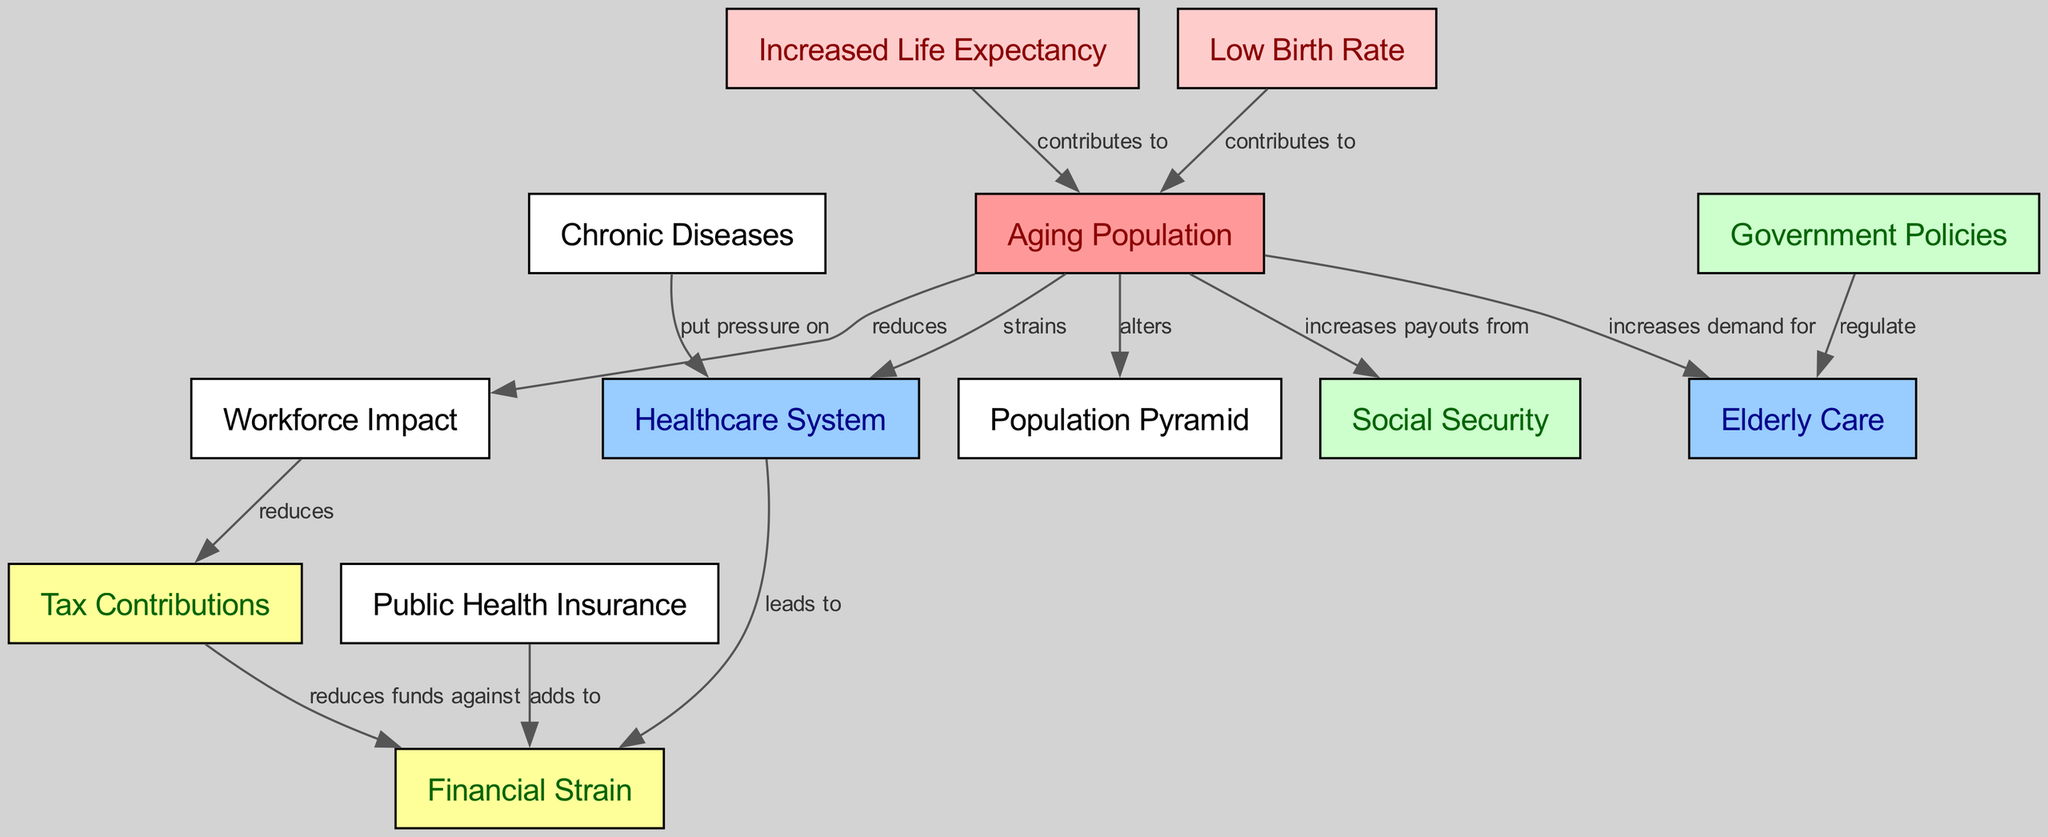What is the main cause contributing to the aging population? According to the diagram, the nodes "Increased Life Expectancy" and "Low Birth Rate" both contribute to "Aging Population." Therefore, either could be selected as a main cause; however, they are specifically indicated to lead to the aging issue.
Answer: Increased Life Expectancy or Low Birth Rate How many nodes are there in total? By counting all the unique entities in the diagram, we find there are 13 individual nodes present related to the aging population crisis and its impact on the healthcare system.
Answer: 13 What relationship does the aging population have with the healthcare system? The diagram shows that the relationship is that the "Aging Population" strains the "Healthcare System." This indicates a direct impact of an increasing elderly population on healthcare resources.
Answer: strains Which factor directly increases demand for elderly care? The diagram specifies that the "Aging Population" leads to an increased demand for "Elderly Care," indicating that the rising elderly demographic is the driving factor for such demand.
Answer: Aging Population What effect does an aging population have on the workforce? The diagram indicates that the aging population reduces the "Workforce Impact," which suggests a negative impact on the workforce's availability or productivity due to an increasing elderly demographic.
Answer: reduces How does public health insurance contribute to financial strain? The diagram specifies that "Public Health Insurance" adds to "Financial Strain," implying that the costs associated with public healthcare coverage become a burden on financial resources in the context of an aging population.
Answer: adds to What is the relationship between tax contributions and financial strain? The diagram shows that "Tax Contributions" reduces funds against "Financial Strain," reflecting that lower tax revenue can lead to less funding available to counter financial pressures caused by an aging population and increased healthcare costs.
Answer: reduces funds against Which element is regulated by government policies? The diagram indicates that "Government Policies" regulate "Elderly Care," suggesting that political action is taken to manage how elderly care services are provided in response to the growing aging population.
Answer: Elderly Care What do chronic diseases put pressure on? The diagram states that "Chronic Diseases" put pressure on the "Healthcare System," indicating that the prevalence of these conditions among the elderly exacerbates the challenges faced by healthcare resources.
Answer: Healthcare System 